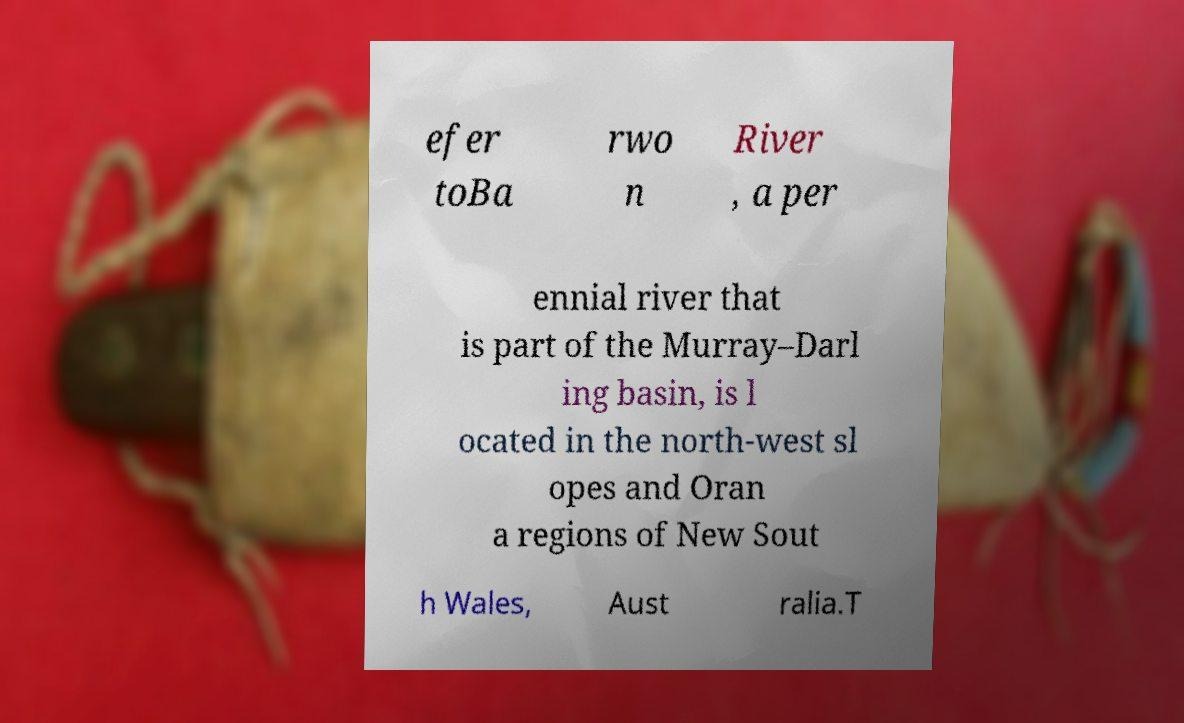What messages or text are displayed in this image? I need them in a readable, typed format. efer toBa rwo n River , a per ennial river that is part of the Murray–Darl ing basin, is l ocated in the north-west sl opes and Oran a regions of New Sout h Wales, Aust ralia.T 